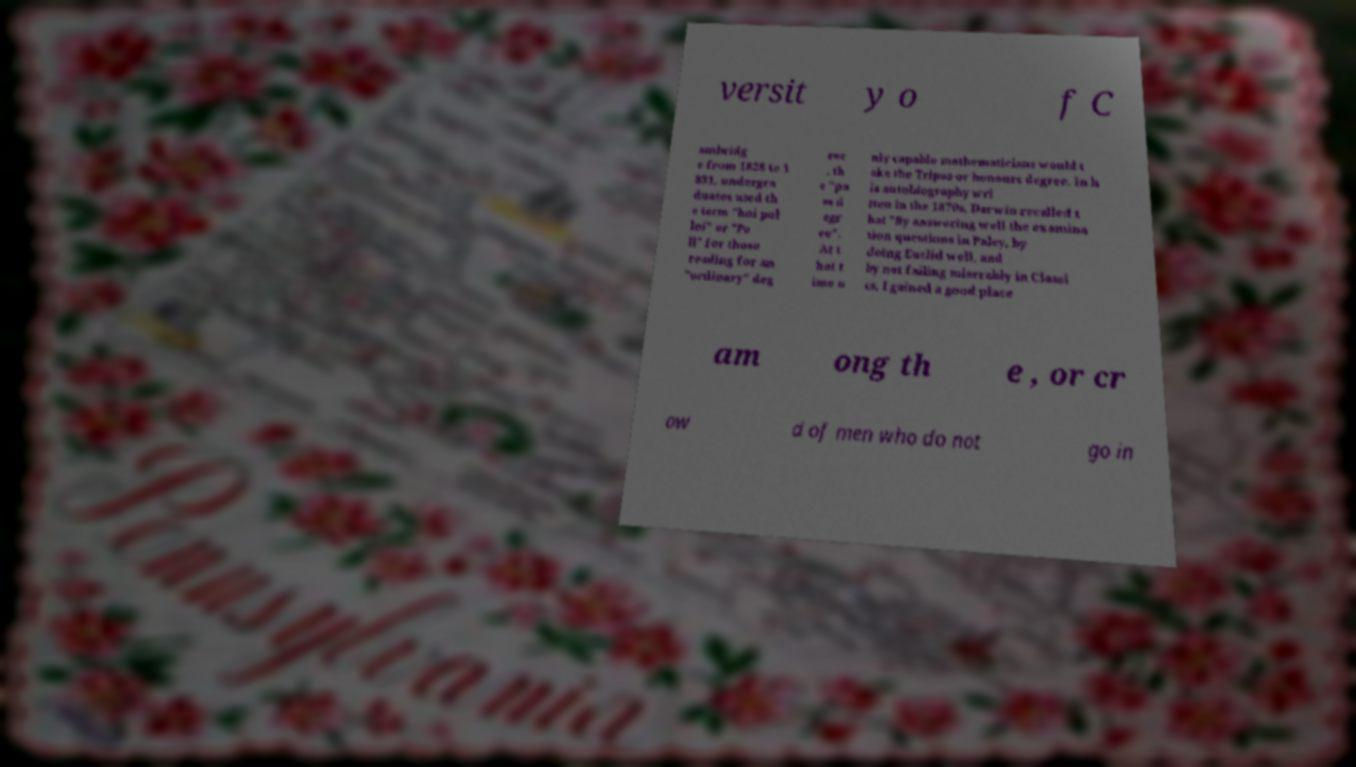There's text embedded in this image that I need extracted. Can you transcribe it verbatim? versit y o f C ambridg e from 1828 to 1 831, undergra duates used th e term "hoi pol loi" or "Po ll" for those reading for an "ordinary" deg ree , th e "pa ss d egr ee". At t hat t ime o nly capable mathematicians would t ake the Tripos or honours degree. In h is autobiography wri tten in the 1870s, Darwin recalled t hat "By answering well the examina tion questions in Paley, by doing Euclid well, and by not failing miserably in Classi cs, I gained a good place am ong th e , or cr ow d of men who do not go in 